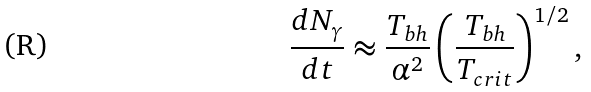Convert formula to latex. <formula><loc_0><loc_0><loc_500><loc_500>\frac { d N _ { \gamma } } { d t } \approx \frac { T _ { b h } } { \alpha ^ { 2 } } \left ( \frac { T _ { b h } } { T _ { c r i t } } \right ) ^ { 1 / 2 } ,</formula> 